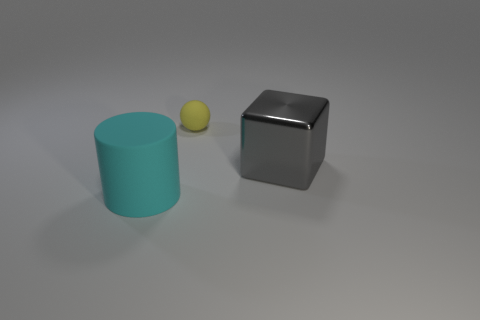Subtract all purple balls. How many blue blocks are left? 0 Add 1 matte balls. How many matte balls are left? 2 Add 2 purple cylinders. How many purple cylinders exist? 2 Add 1 tiny cylinders. How many objects exist? 4 Subtract 0 brown spheres. How many objects are left? 3 Subtract all cylinders. How many objects are left? 2 Subtract 1 cylinders. How many cylinders are left? 0 Subtract all yellow objects. Subtract all big matte cylinders. How many objects are left? 1 